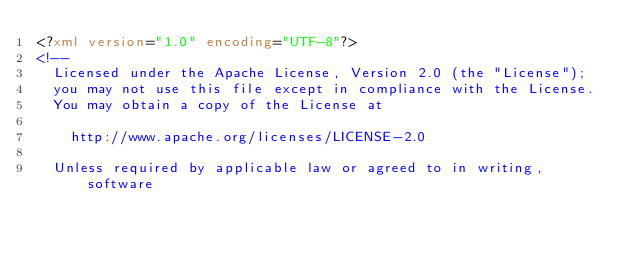<code> <loc_0><loc_0><loc_500><loc_500><_XML_><?xml version="1.0" encoding="UTF-8"?>
<!--
  Licensed under the Apache License, Version 2.0 (the "License");
  you may not use this file except in compliance with the License.
  You may obtain a copy of the License at

    http://www.apache.org/licenses/LICENSE-2.0

  Unless required by applicable law or agreed to in writing, software</code> 